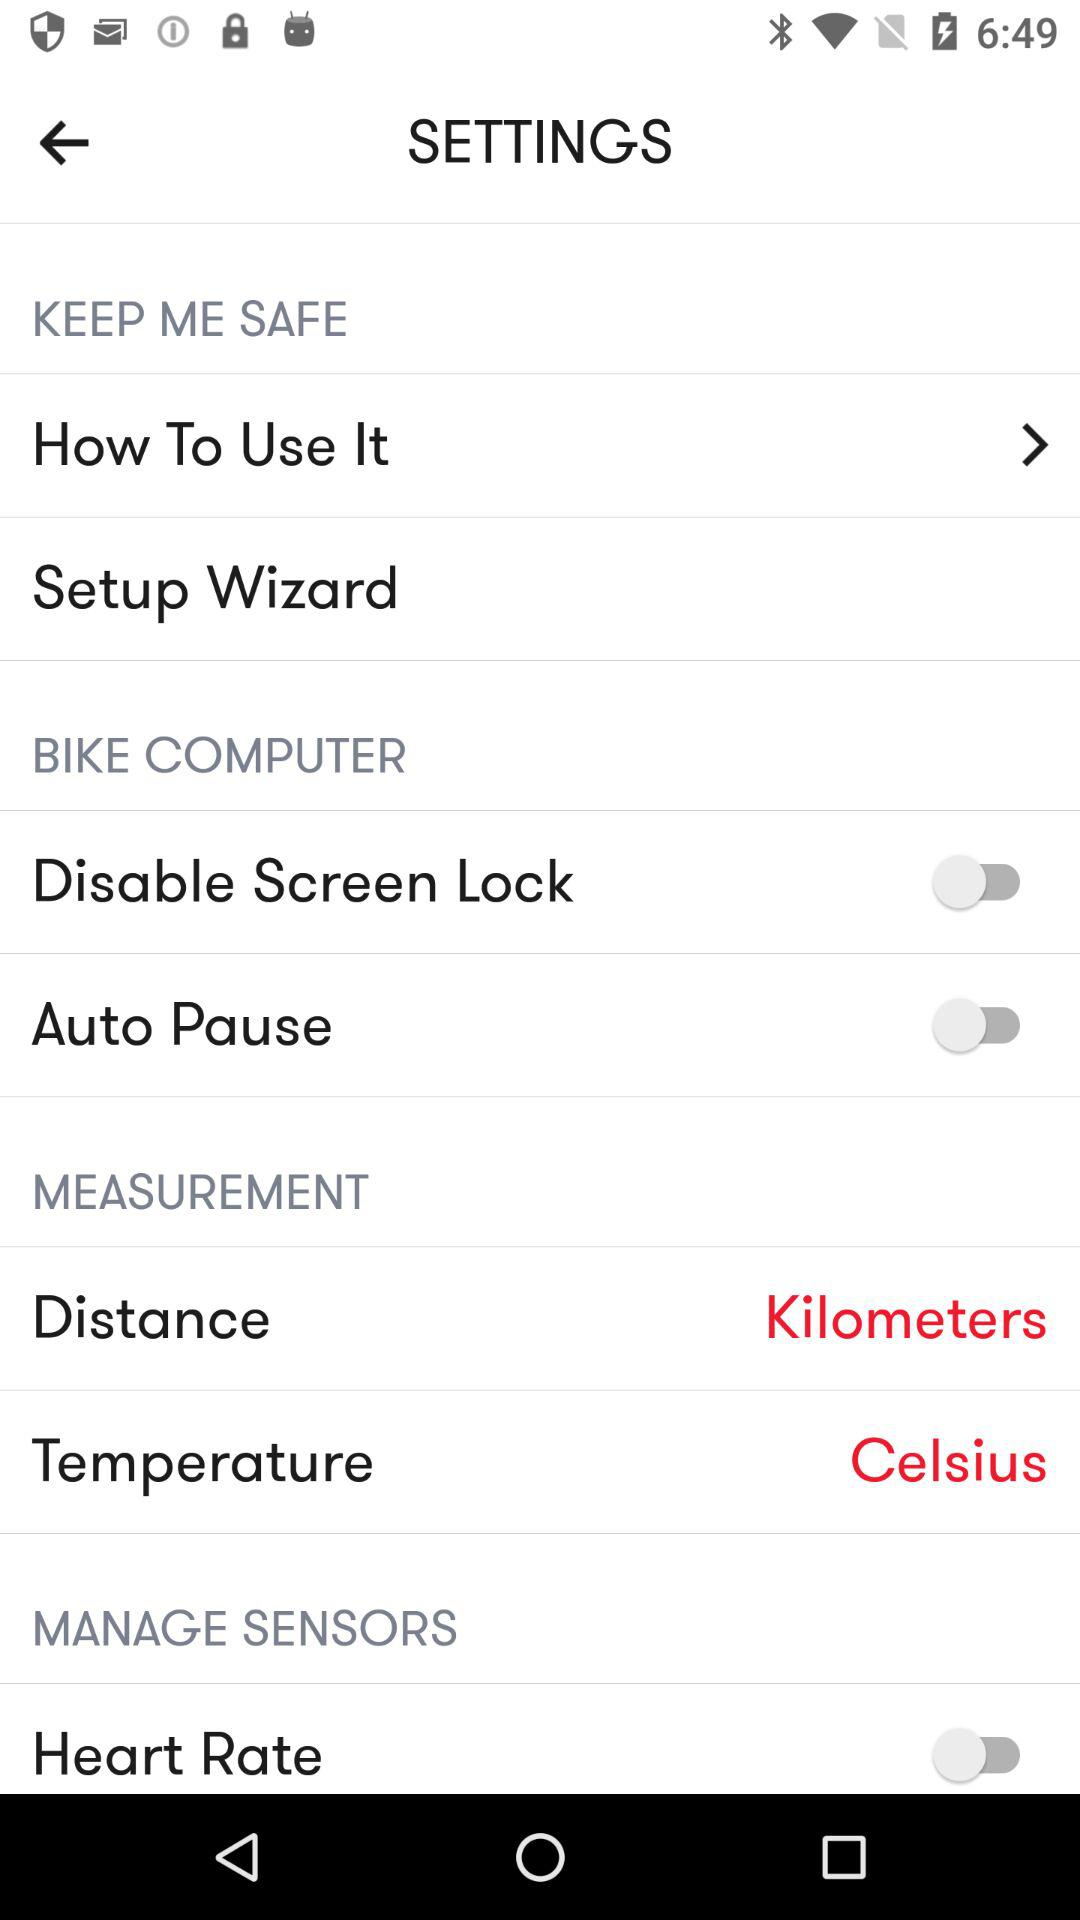How many items can be selected from the measurement menu?
Answer the question using a single word or phrase. 2 